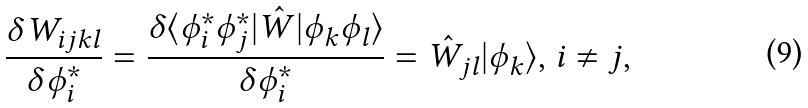<formula> <loc_0><loc_0><loc_500><loc_500>\frac { \delta W _ { i j k l } } { \delta \phi ^ { * } _ { i } } = \frac { \delta \langle \phi ^ { * } _ { i } \phi ^ { * } _ { j } | \hat { W } | \phi _ { k } \phi _ { l } \rangle } { \delta \phi ^ { * } _ { i } } = \hat { W } _ { j l } | \phi _ { k } \rangle , \, i \ne j ,</formula> 